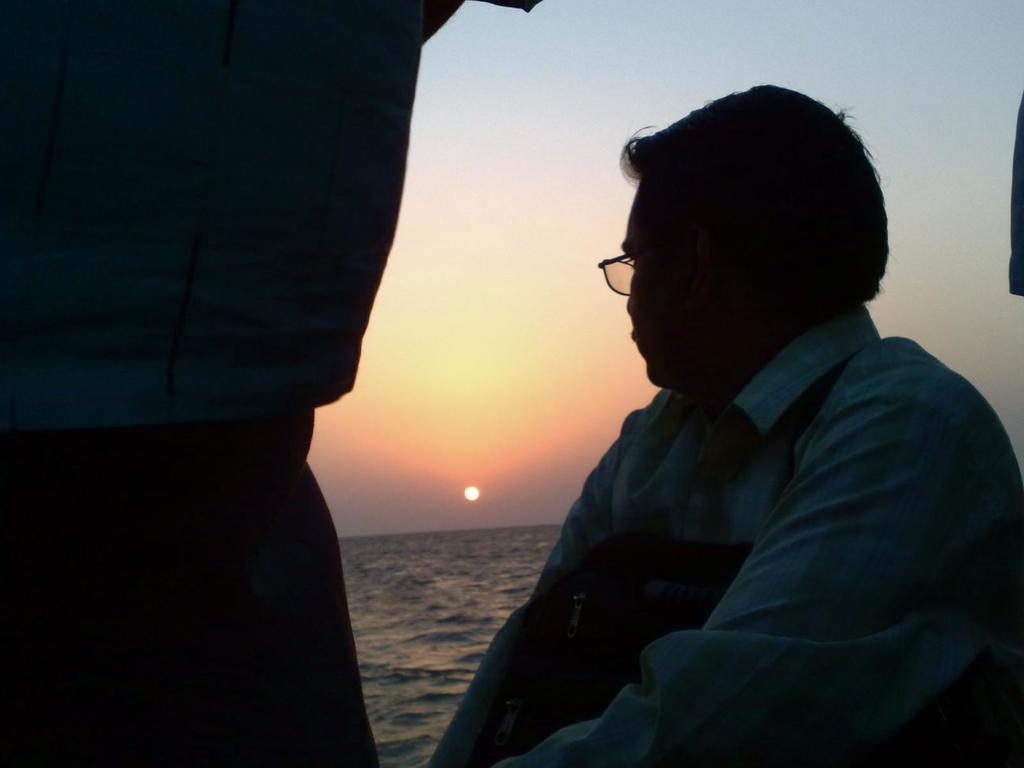How would you summarize this image in a sentence or two? In the bottom right corner of the image a person is sitting and watching. At the top right corner of the image we can see sun in the sky. On the left side of the image we can see a person. 